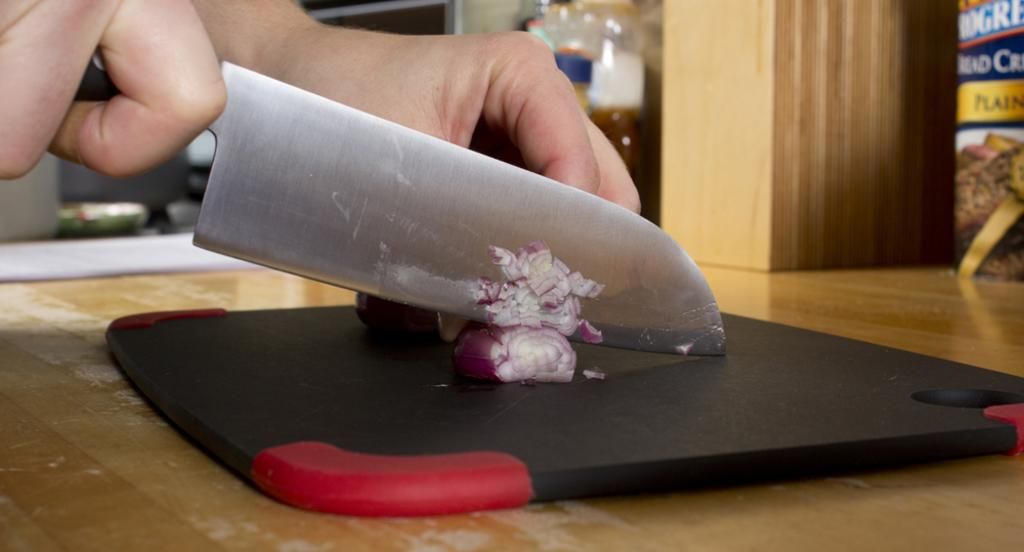What part of a person can be seen in the image? There is a person's hand in the image. What is the person doing with their hand? The person is chopping an onion. What tool is being used for chopping? A knife is being used for chopping. What surface is the person using for chopping? There is a chopping board in the image. What type of ocean can be seen in the background of the image? There is no ocean present in the image; it features a person's hand chopping an onion. 